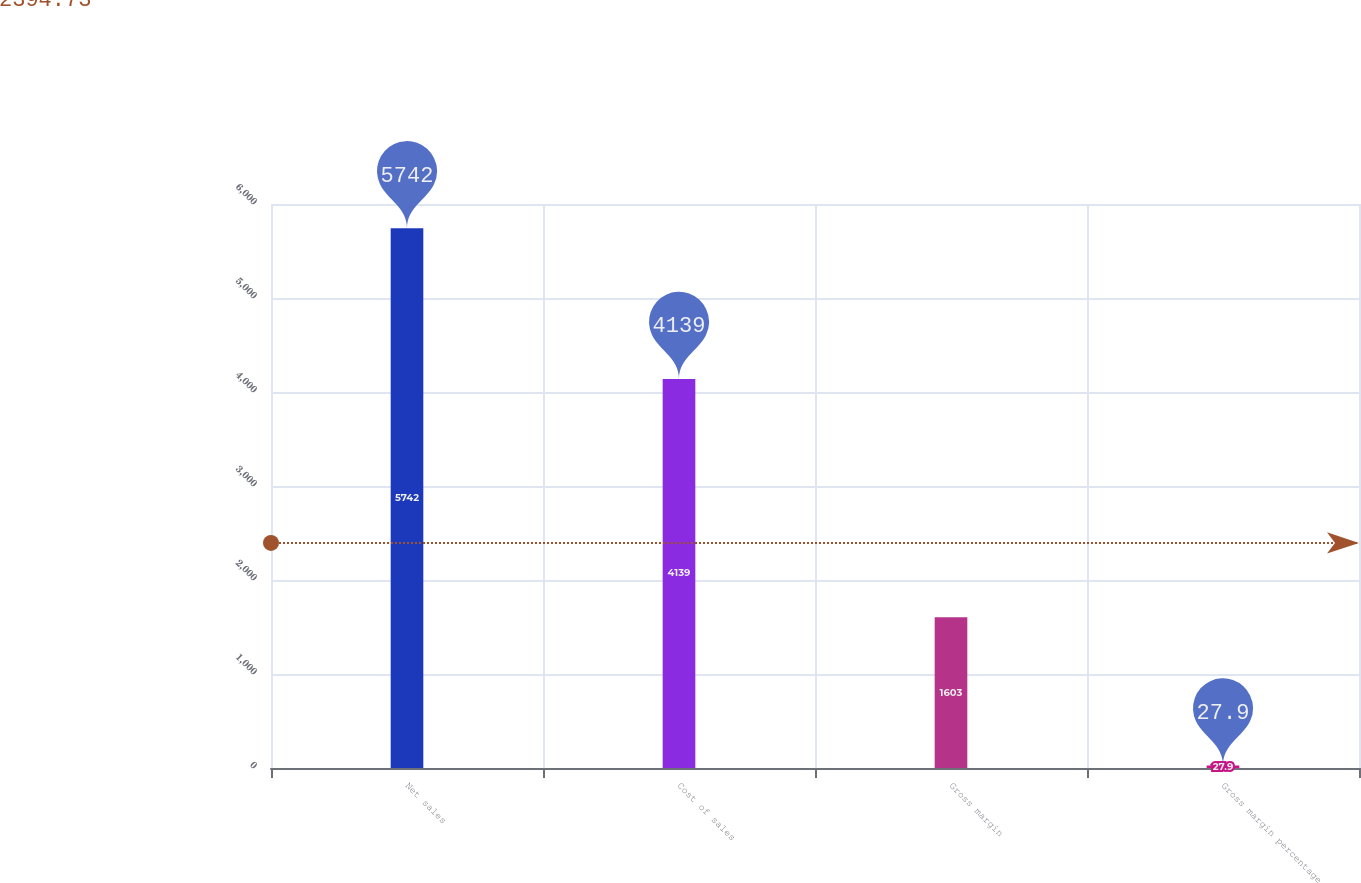Convert chart to OTSL. <chart><loc_0><loc_0><loc_500><loc_500><bar_chart><fcel>Net sales<fcel>Cost of sales<fcel>Gross margin<fcel>Gross margin percentage<nl><fcel>5742<fcel>4139<fcel>1603<fcel>27.9<nl></chart> 